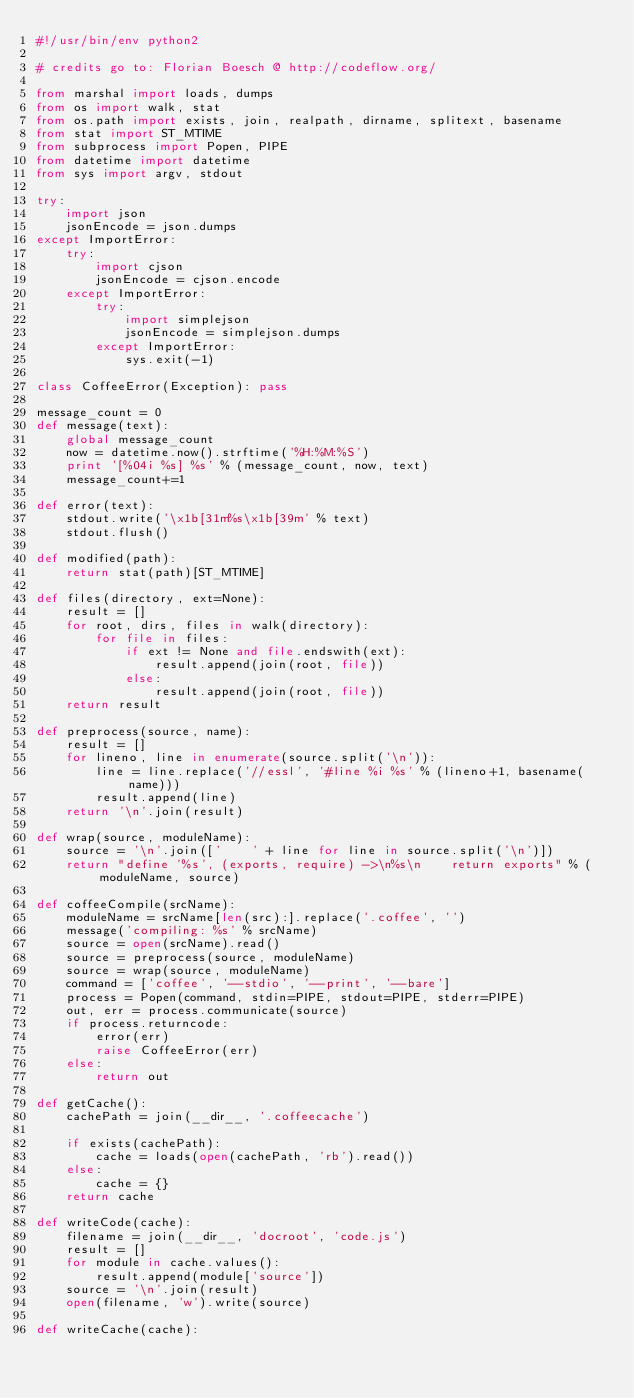Convert code to text. <code><loc_0><loc_0><loc_500><loc_500><_Python_>#!/usr/bin/env python2

# credits go to: Florian Boesch @ http://codeflow.org/

from marshal import loads, dumps
from os import walk, stat
from os.path import exists, join, realpath, dirname, splitext, basename
from stat import ST_MTIME
from subprocess import Popen, PIPE
from datetime import datetime
from sys import argv, stdout

try:
    import json
    jsonEncode = json.dumps
except ImportError:
    try:
        import cjson
        jsonEncode = cjson.encode
    except ImportError:
        try:
            import simplejson
            jsonEncode = simplejson.dumps
        except ImportError:
            sys.exit(-1)

class CoffeeError(Exception): pass

message_count = 0
def message(text):
    global message_count
    now = datetime.now().strftime('%H:%M:%S')
    print '[%04i %s] %s' % (message_count, now, text)
    message_count+=1

def error(text):
    stdout.write('\x1b[31m%s\x1b[39m' % text)
    stdout.flush()

def modified(path):
    return stat(path)[ST_MTIME]

def files(directory, ext=None):
    result = []
    for root, dirs, files in walk(directory):
        for file in files:
            if ext != None and file.endswith(ext):
                result.append(join(root, file))
            else:
                result.append(join(root, file))
    return result

def preprocess(source, name):
    result = []
    for lineno, line in enumerate(source.split('\n')):
        line = line.replace('//essl', '#line %i %s' % (lineno+1, basename(name)))
        result.append(line)
    return '\n'.join(result)

def wrap(source, moduleName):
    source = '\n'.join(['    ' + line for line in source.split('\n')])
    return "define '%s', (exports, require) ->\n%s\n    return exports" % (moduleName, source)

def coffeeCompile(srcName):
    moduleName = srcName[len(src):].replace('.coffee', '')
    message('compiling: %s' % srcName)
    source = open(srcName).read()
    source = preprocess(source, moduleName)
    source = wrap(source, moduleName)
    command = ['coffee', '--stdio', '--print', '--bare']
    process = Popen(command, stdin=PIPE, stdout=PIPE, stderr=PIPE)
    out, err = process.communicate(source)
    if process.returncode:
        error(err)
        raise CoffeeError(err)
    else:
        return out

def getCache():
    cachePath = join(__dir__, '.coffeecache')

    if exists(cachePath):
        cache = loads(open(cachePath, 'rb').read())
    else:
        cache = {}
    return cache

def writeCode(cache):
    filename = join(__dir__, 'docroot', 'code.js')
    result = []
    for module in cache.values():
        result.append(module['source'])
    source = '\n'.join(result)
    open(filename, 'w').write(source)

def writeCache(cache):</code> 